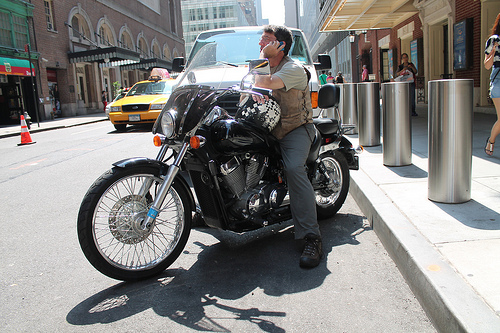What type of motorcycle is in the image? The image features a black cruiser-style motorcycle, which is known for its extended fork and larger displacement engine. 